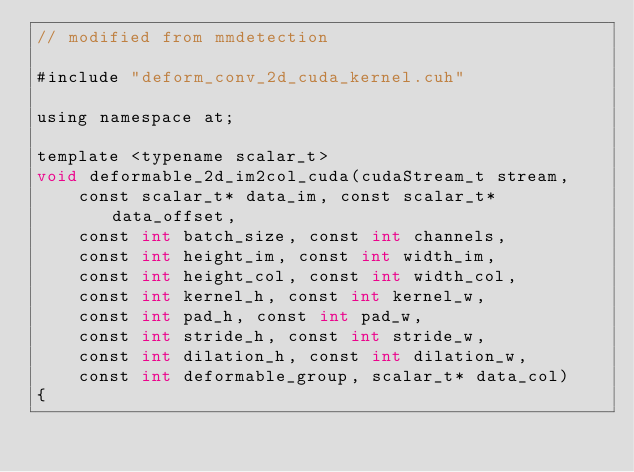<code> <loc_0><loc_0><loc_500><loc_500><_Cuda_>// modified from mmdetection

#include "deform_conv_2d_cuda_kernel.cuh"

using namespace at;

template <typename scalar_t>
void deformable_2d_im2col_cuda(cudaStream_t stream,
    const scalar_t* data_im, const scalar_t* data_offset,
    const int batch_size, const int channels,
    const int height_im, const int width_im,
    const int height_col, const int width_col,
    const int kernel_h, const int kernel_w,
    const int pad_h, const int pad_w,
    const int stride_h, const int stride_w,
    const int dilation_h, const int dilation_w,
    const int deformable_group, scalar_t* data_col)
{</code> 